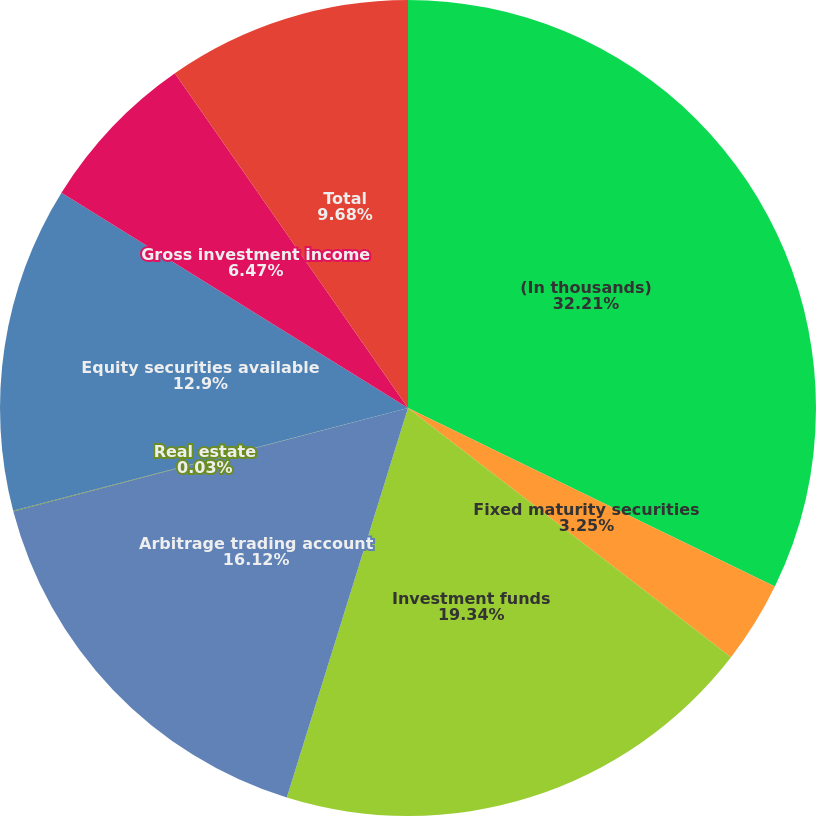Convert chart to OTSL. <chart><loc_0><loc_0><loc_500><loc_500><pie_chart><fcel>(In thousands)<fcel>Fixed maturity securities<fcel>Investment funds<fcel>Arbitrage trading account<fcel>Real estate<fcel>Equity securities available<fcel>Gross investment income<fcel>Total<nl><fcel>32.21%<fcel>3.25%<fcel>19.34%<fcel>16.12%<fcel>0.03%<fcel>12.9%<fcel>6.47%<fcel>9.68%<nl></chart> 